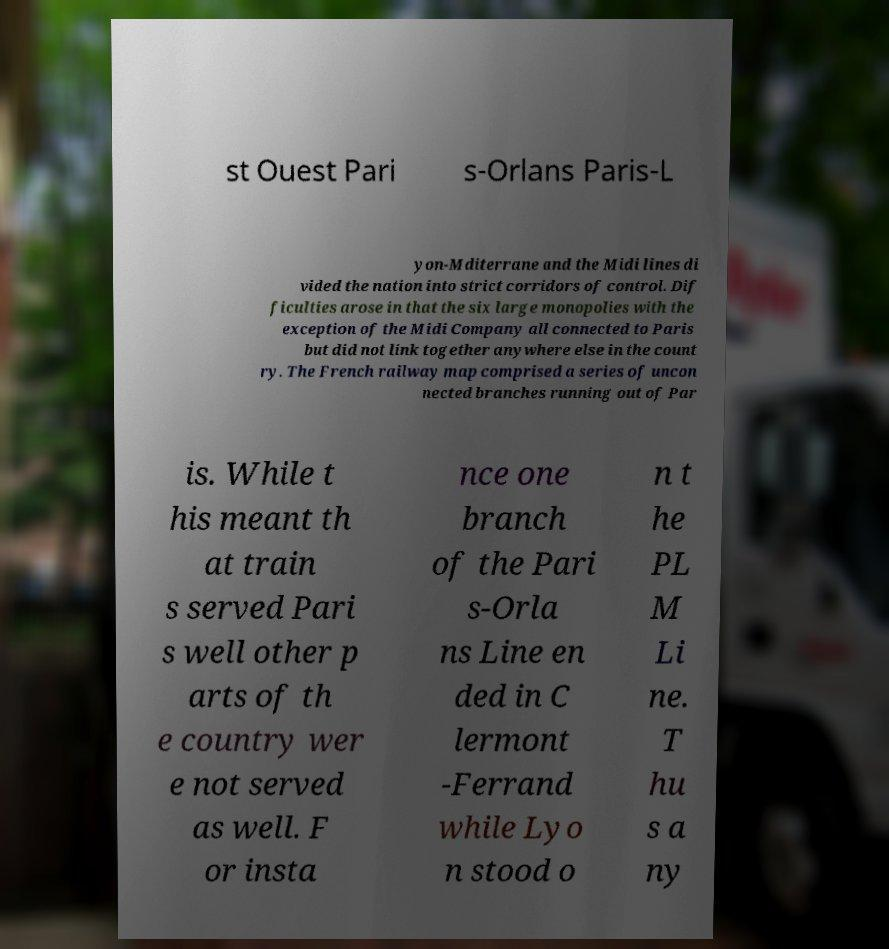Can you read and provide the text displayed in the image?This photo seems to have some interesting text. Can you extract and type it out for me? st Ouest Pari s-Orlans Paris-L yon-Mditerrane and the Midi lines di vided the nation into strict corridors of control. Dif ficulties arose in that the six large monopolies with the exception of the Midi Company all connected to Paris but did not link together anywhere else in the count ry. The French railway map comprised a series of uncon nected branches running out of Par is. While t his meant th at train s served Pari s well other p arts of th e country wer e not served as well. F or insta nce one branch of the Pari s-Orla ns Line en ded in C lermont -Ferrand while Lyo n stood o n t he PL M Li ne. T hu s a ny 